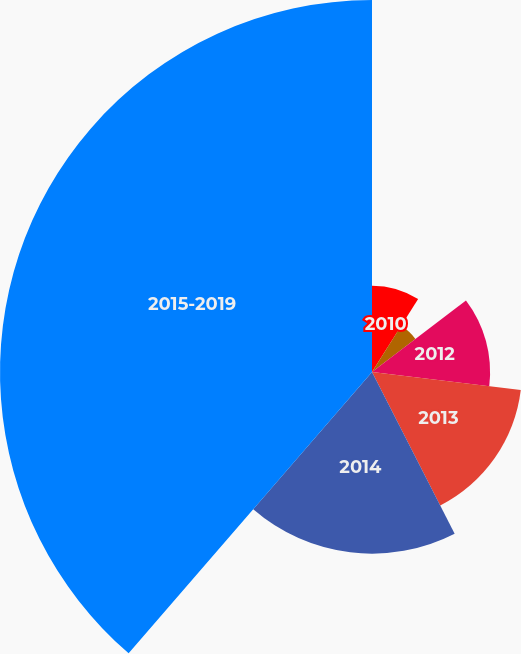Convert chart to OTSL. <chart><loc_0><loc_0><loc_500><loc_500><pie_chart><fcel>2010<fcel>2011<fcel>2012<fcel>2013<fcel>2014<fcel>2015-2019<nl><fcel>8.97%<fcel>5.67%<fcel>12.27%<fcel>15.57%<fcel>18.87%<fcel>38.65%<nl></chart> 